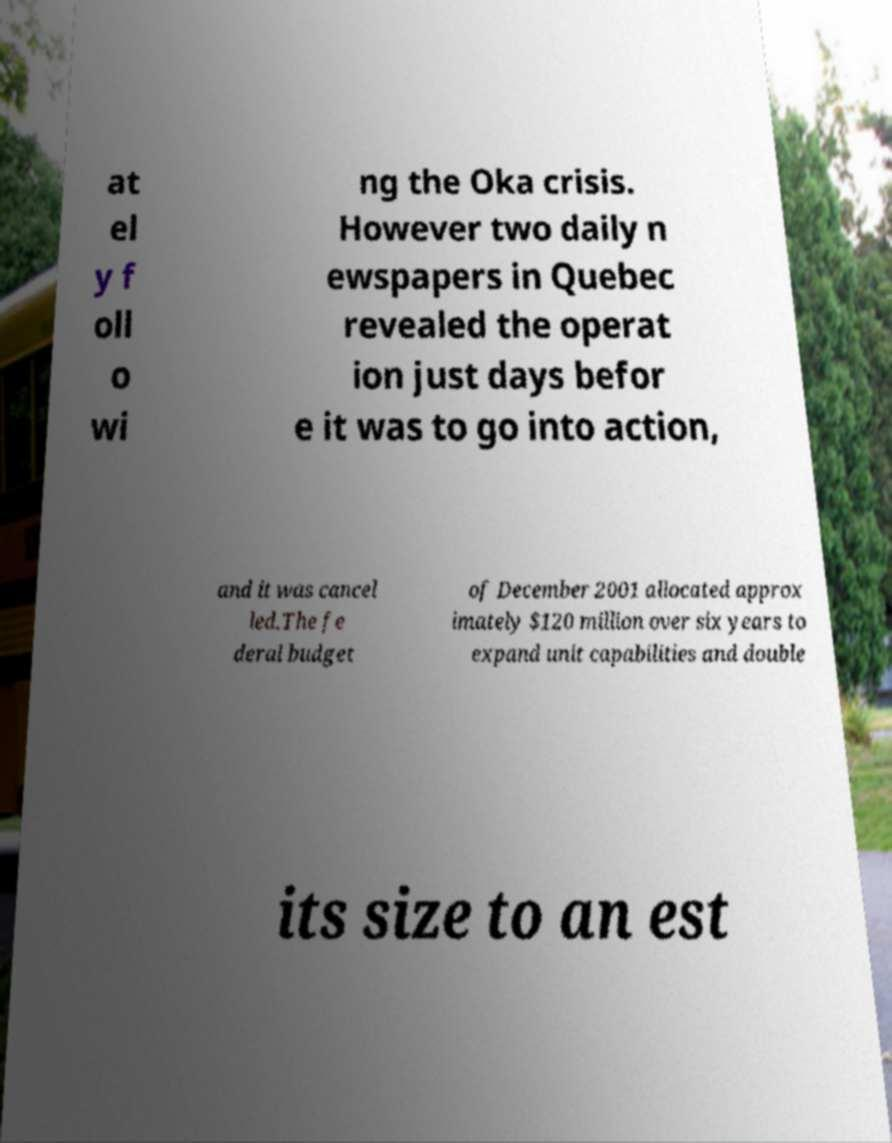What messages or text are displayed in this image? I need them in a readable, typed format. at el y f oll o wi ng the Oka crisis. However two daily n ewspapers in Quebec revealed the operat ion just days befor e it was to go into action, and it was cancel led.The fe deral budget of December 2001 allocated approx imately $120 million over six years to expand unit capabilities and double its size to an est 